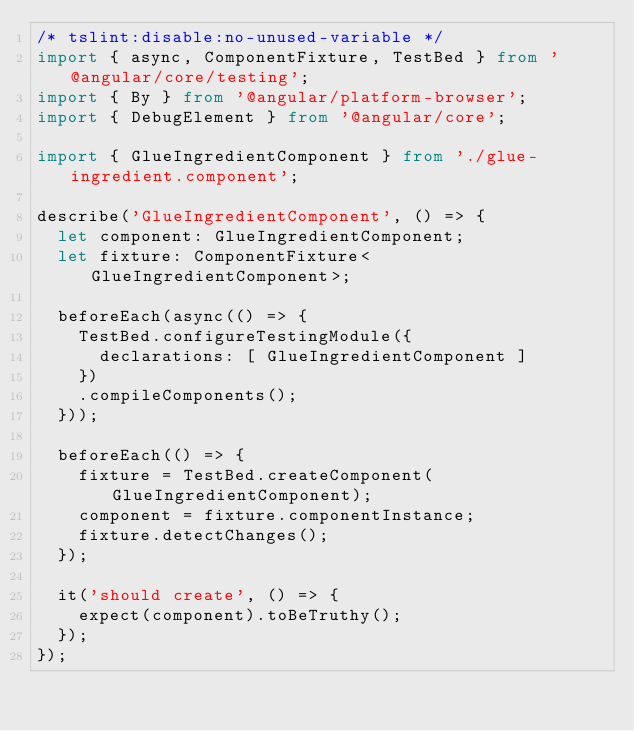<code> <loc_0><loc_0><loc_500><loc_500><_TypeScript_>/* tslint:disable:no-unused-variable */
import { async, ComponentFixture, TestBed } from '@angular/core/testing';
import { By } from '@angular/platform-browser';
import { DebugElement } from '@angular/core';

import { GlueIngredientComponent } from './glue-ingredient.component';

describe('GlueIngredientComponent', () => {
  let component: GlueIngredientComponent;
  let fixture: ComponentFixture<GlueIngredientComponent>;

  beforeEach(async(() => {
    TestBed.configureTestingModule({
      declarations: [ GlueIngredientComponent ]
    })
    .compileComponents();
  }));

  beforeEach(() => {
    fixture = TestBed.createComponent(GlueIngredientComponent);
    component = fixture.componentInstance;
    fixture.detectChanges();
  });

  it('should create', () => {
    expect(component).toBeTruthy();
  });
});
</code> 